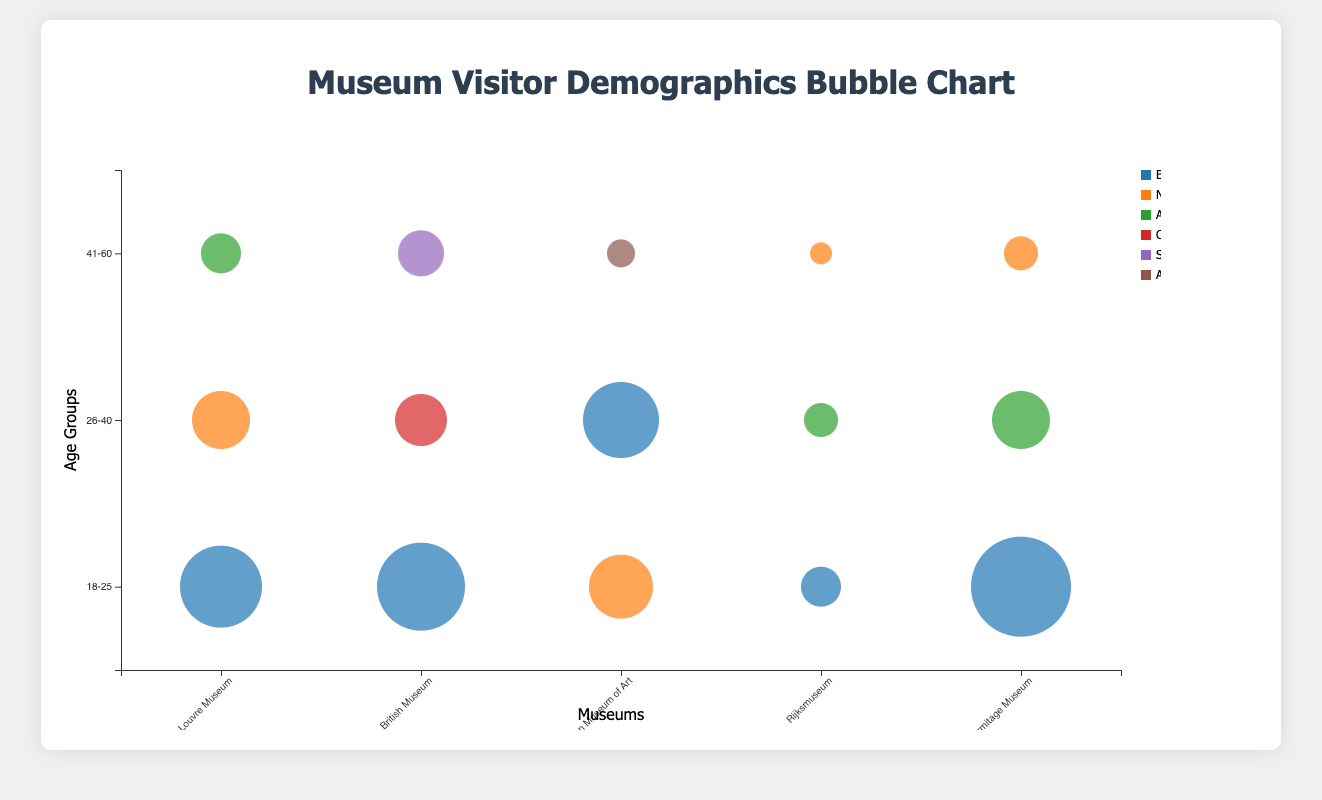What is the title of the chart? The title can be found at the top of the chart and it summarizes the overall content.
Answer: Museum Visitor Demographics Bubble Chart Which museum has the highest number of visitors in the 18-25 age group? Look for the largest bubble in the age group "18-25" and see which museum it corresponds to.
Answer: Hermitage Museum What are the x-axis and y-axis labels? X-axis represents museums, and Y-axis represents age groups. By reading from the bottom and left side of the chart, you can find these labels.
Answer: Museums, Age Groups How many unique locations are represented in the chart? Each unique color corresponds to a different location. The legend shows all the unique locations. Count the distinct labels in the legend.
Answer: 7 Which museum has the largest number of female visitors aged 41-60? Locate the line corresponding to "41-60" on the y-axis, and look for the largest bubble filled with the color representing Female gender.
Answer: Louvre Museum How many female visitors aged 18-25 visit the Louvre Museum? Find the bubble corresponding to Louvre Museum and "18-25" age group, and check the data provided by the tooltip on hover.
Answer: 12,000 Compare the number of visitors from Europe at the Louvre Museum with the Hermitage Museum. Which one has more? Identify bubbles representing Europe in both museums and compare their sizes or visitors count shown by the tooltip.
Answer: Hermitage Museum What is the sum of visitors aged 26-40 at the British Museum and the Louvre Museum? Locate the bubbles for age group "26-40" in these museums, and sum the visitors.
Answer: 15,000 (7,000 + 8,000) Which age group has the smallest bubble for the Metropolitan Museum of Art, and how many visitors are there? Compare the size of all bubbles for the Metropolitan Museum of Art and identify the smallest one.
Answer: 41-60, 3,000 Is there a museum where every location category has at least one bubble? Look for a museum that covers all unique colors in its section. If a museum has bubbles corresponding to all location legends.
Answer: No 